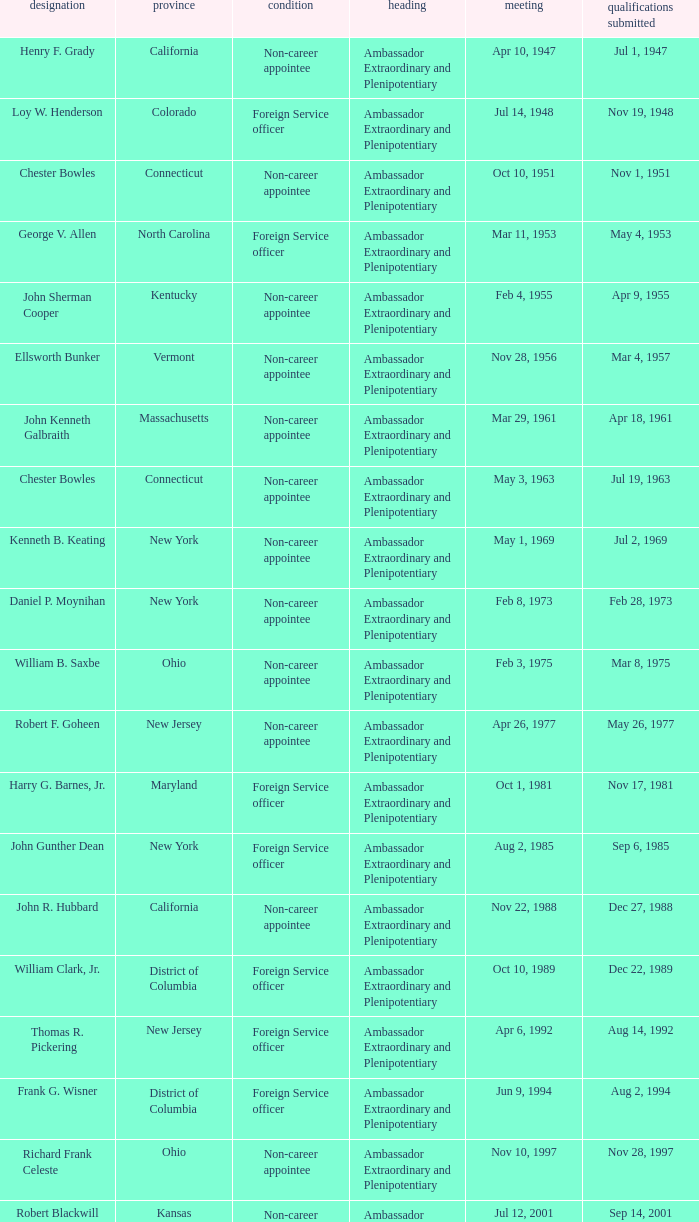When were the credentials presented for new jersey with a status of foreign service officer? Aug 14, 1992. 